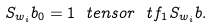<formula> <loc_0><loc_0><loc_500><loc_500>S _ { w _ { i } } b _ { 0 } = 1 \ t e n s o r \ t f _ { 1 } S _ { w _ { i } } b .</formula> 